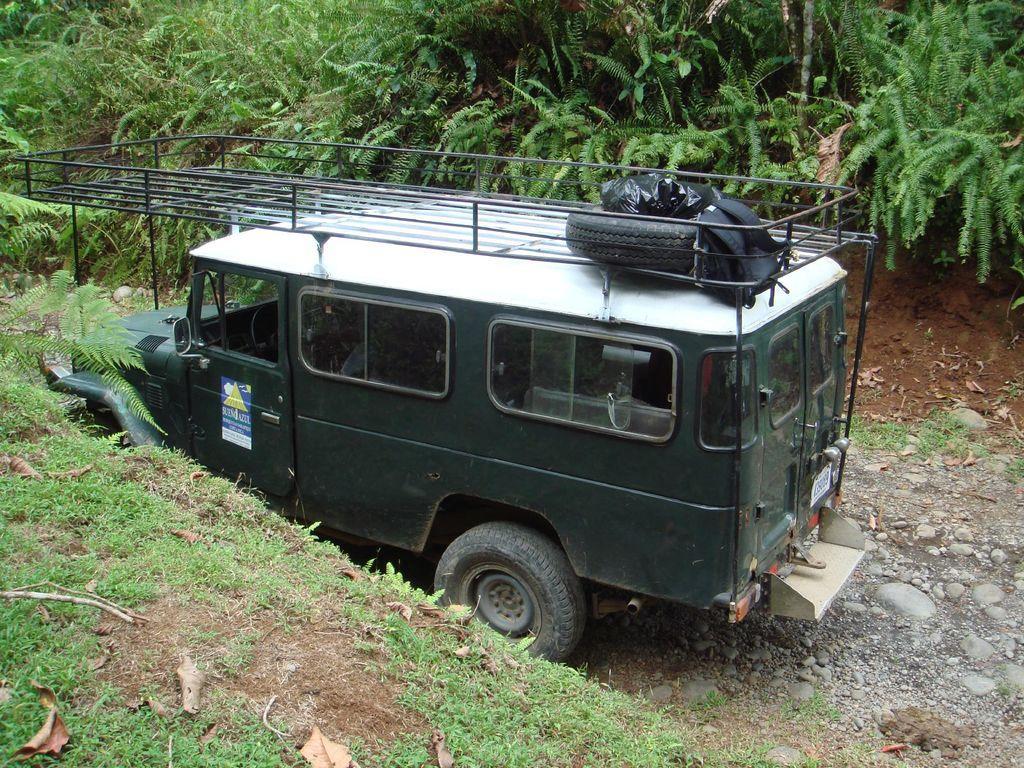How would you summarize this image in a sentence or two? In this image we can see a vehicle. There are some trees, plants, stones, leaves and grass on the ground. 